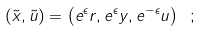<formula> <loc_0><loc_0><loc_500><loc_500>\left ( \tilde { x } , \tilde { u } \right ) = \left ( e ^ { \epsilon } r , e ^ { \epsilon } y , e ^ { - \epsilon } u \right ) \ ;</formula> 